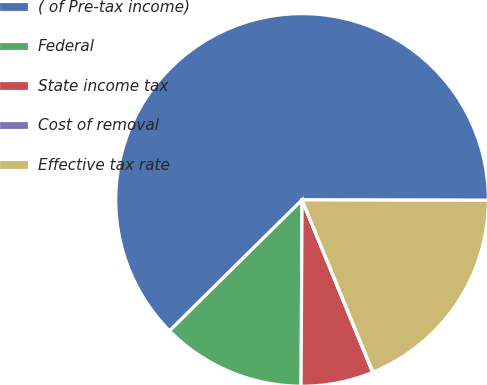Convert chart. <chart><loc_0><loc_0><loc_500><loc_500><pie_chart><fcel>( of Pre-tax income)<fcel>Federal<fcel>State income tax<fcel>Cost of removal<fcel>Effective tax rate<nl><fcel>62.43%<fcel>12.51%<fcel>6.27%<fcel>0.03%<fcel>18.75%<nl></chart> 